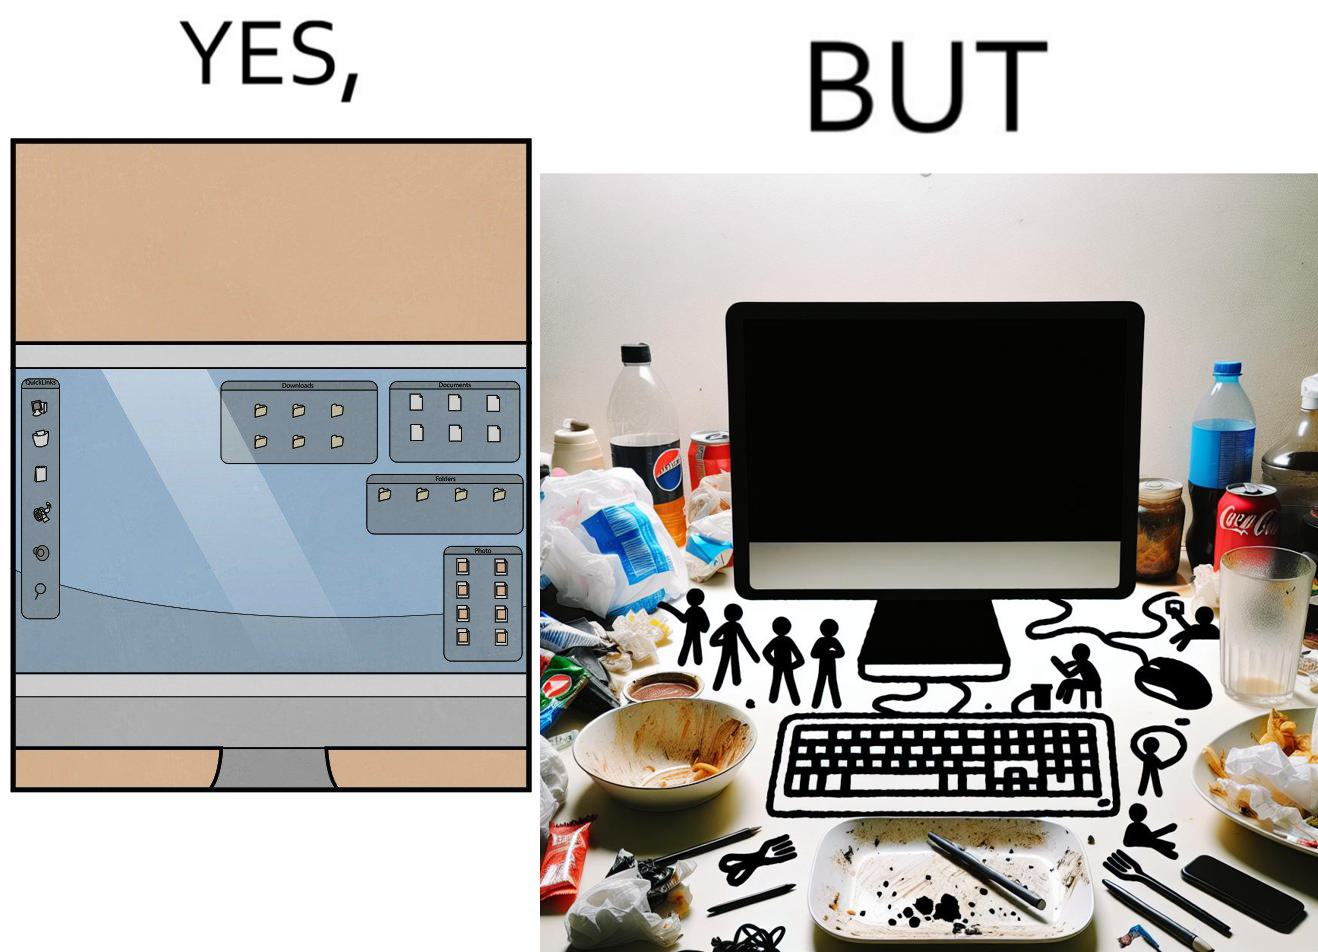Would you classify this image as satirical? Yes, this image is satirical. 